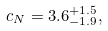<formula> <loc_0><loc_0><loc_500><loc_500>c _ { N } = 3 . 6 ^ { + 1 . 5 } _ { - 1 . 9 } ,</formula> 